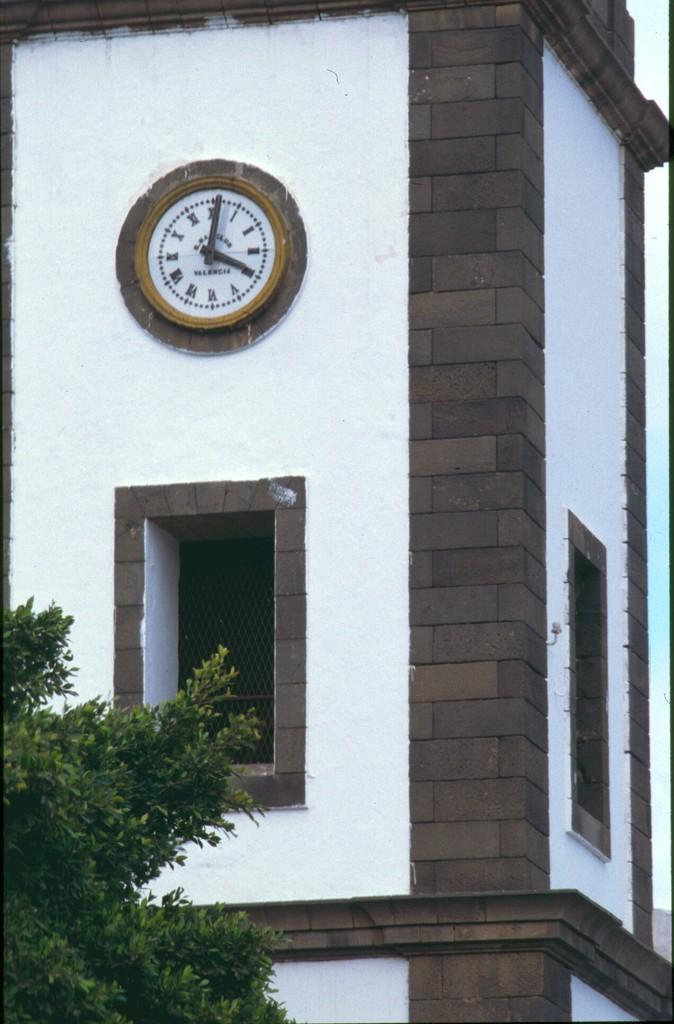In one or two sentences, can you explain what this image depicts? In this picture we can see clock on the wall, and also we can see a tree. 